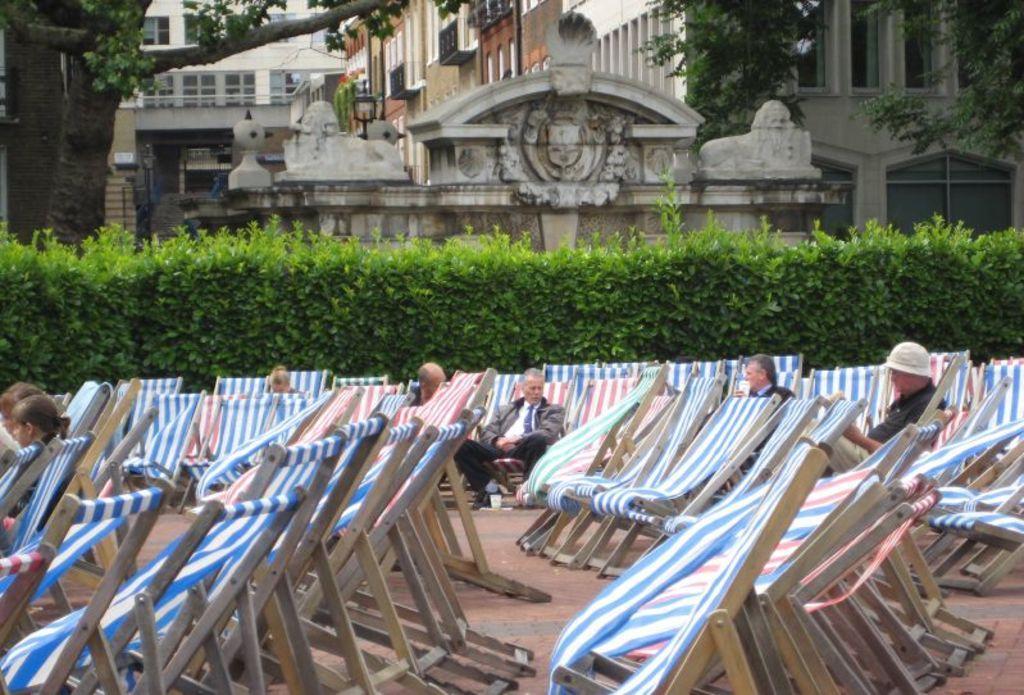In one or two sentences, can you explain what this image depicts? At the bottom of the image I can see few people are sitting on the chairs and also there are many empty chairs. At the back there are some plants. In the background, I can see few buildings and trees. 